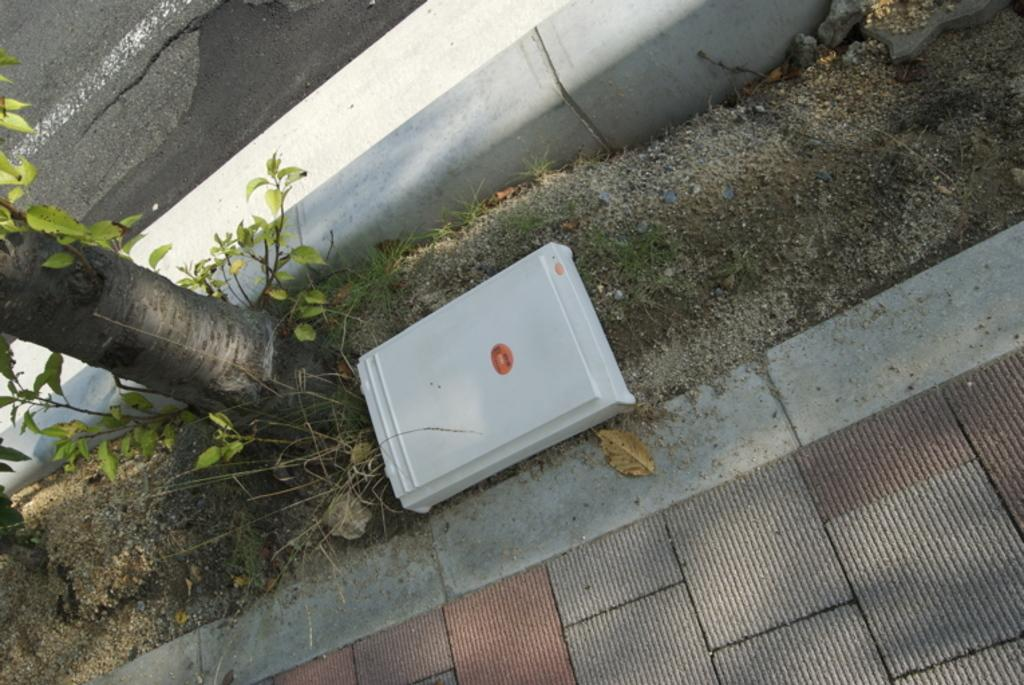What is the main object in the center of the image? There is a box in the center of the image. Where is the box located? The box is on the ground. What type of pathway can be seen in the image? There is a side way in the image. What kind of plant is present in the image? There is a tree with leaves in the image. What type of transportation route is visible at the top of the image? There is a road visible at the top of the image. What type of structure is present in the image? There is a wall in the image. How much tax is being paid on the hydrant in the image? There is no hydrant present in the image, so tax payment cannot be determined. What type of ball is being used to play with the tree in the image? There is no ball present in the image, and the tree is not being used for play. 